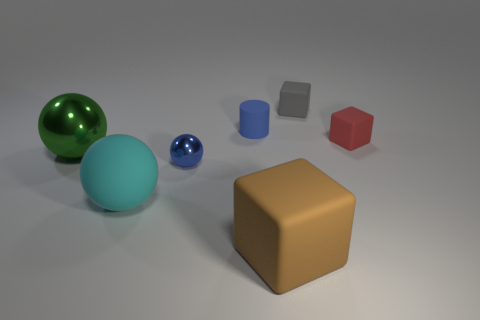Is the large matte ball the same color as the small metal object?
Provide a succinct answer. No. Is the gray cube made of the same material as the tiny ball?
Your response must be concise. No. Is there a small thing of the same color as the tiny matte cylinder?
Provide a short and direct response. Yes. There is a gray object that is the same size as the blue ball; what shape is it?
Make the answer very short. Cube. The small rubber cube that is in front of the small gray block is what color?
Ensure brevity in your answer.  Red. Are there any green metallic things behind the ball that is behind the tiny blue metal thing?
Provide a succinct answer. No. How many things are either rubber things in front of the green thing or shiny spheres?
Provide a short and direct response. 4. What is the material of the big sphere that is behind the big rubber object on the left side of the large block?
Keep it short and to the point. Metal. Are there the same number of big rubber things in front of the big rubber cube and rubber blocks that are behind the small blue matte cylinder?
Give a very brief answer. No. How many things are either matte cubes behind the tiny blue matte thing or rubber things to the right of the small blue matte cylinder?
Keep it short and to the point. 3. 